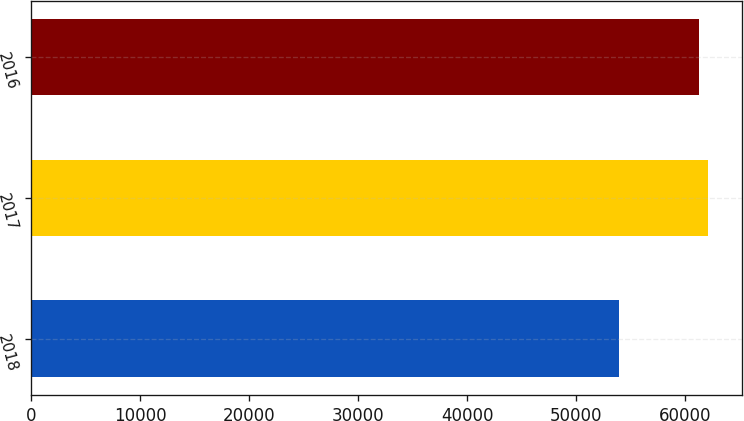Convert chart to OTSL. <chart><loc_0><loc_0><loc_500><loc_500><bar_chart><fcel>2018<fcel>2017<fcel>2016<nl><fcel>53893<fcel>62098<fcel>61225<nl></chart> 